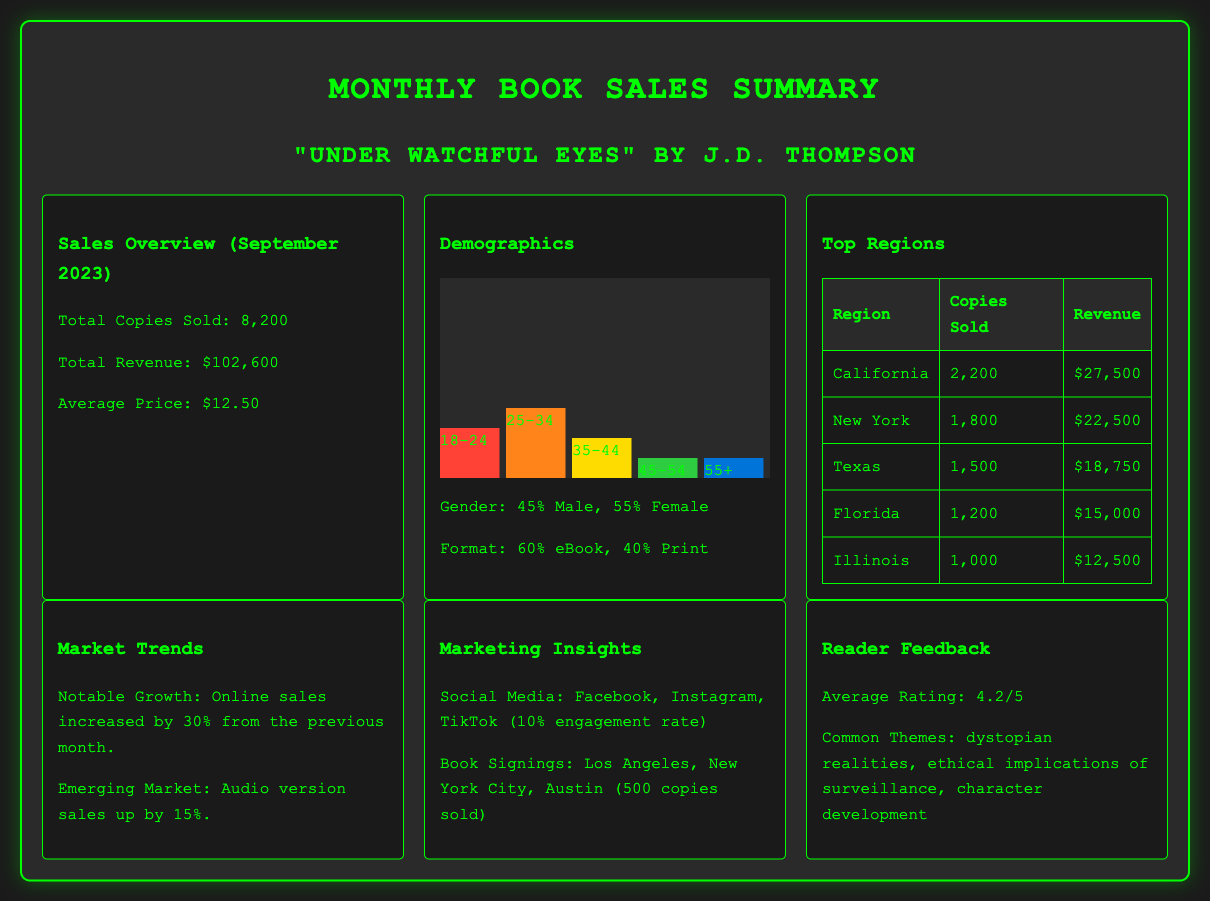What is the total copies sold? The total copies sold is provided in the sales overview section of the document, which states 8,200.
Answer: 8,200 What is the average price of the book? The average price is listed in the sales overview and it is $12.50.
Answer: $12.50 What percentage of sales were from the 25-34 age group? The demographics section states that 35% of the sales were from the 25-34 age group.
Answer: 35% Which state sold the most copies? The top regions table indicates that California had the highest sales of 2,200 copies.
Answer: California What is the notable growth in online sales? Under the market trends, it states that online sales increased by 30%.
Answer: 30% How many copies were sold in Florida? The top regions table provides the number of copies sold in Florida, which is 1,200.
Answer: 1,200 What is the average rating of the book? The reader feedback section reveals that the average rating is 4.2 out of 5.
Answer: 4.2 What percentage of readers were male? The demographics section specifies that 45% of the readers were male.
Answer: 45% What marketing channel had a 10% engagement rate? The marketing insights section lists social media platforms with a 10% engagement rate.
Answer: Social Media 